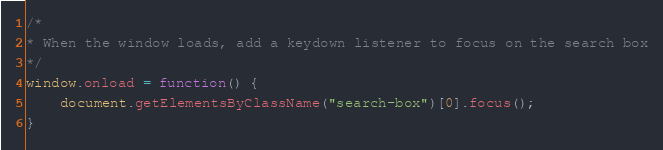Convert code to text. <code><loc_0><loc_0><loc_500><loc_500><_JavaScript_>
/*
* When the window loads, add a keydown listener to focus on the search box
*/
window.onload = function() {
	document.getElementsByClassName("search-box")[0].focus();
}</code> 